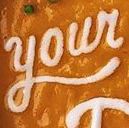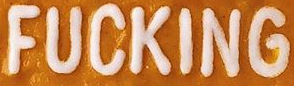Read the text content from these images in order, separated by a semicolon. Your; FUCKING 